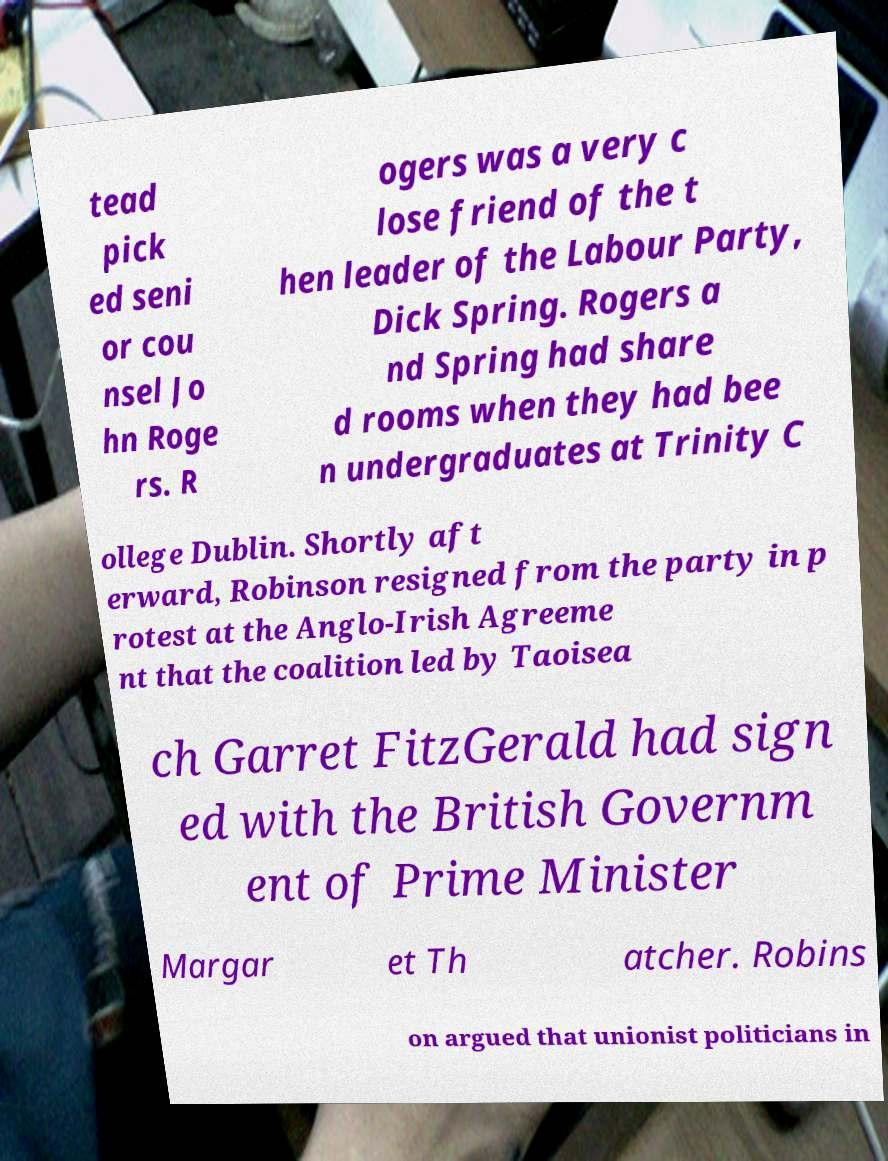What messages or text are displayed in this image? I need them in a readable, typed format. tead pick ed seni or cou nsel Jo hn Roge rs. R ogers was a very c lose friend of the t hen leader of the Labour Party, Dick Spring. Rogers a nd Spring had share d rooms when they had bee n undergraduates at Trinity C ollege Dublin. Shortly aft erward, Robinson resigned from the party in p rotest at the Anglo-Irish Agreeme nt that the coalition led by Taoisea ch Garret FitzGerald had sign ed with the British Governm ent of Prime Minister Margar et Th atcher. Robins on argued that unionist politicians in 